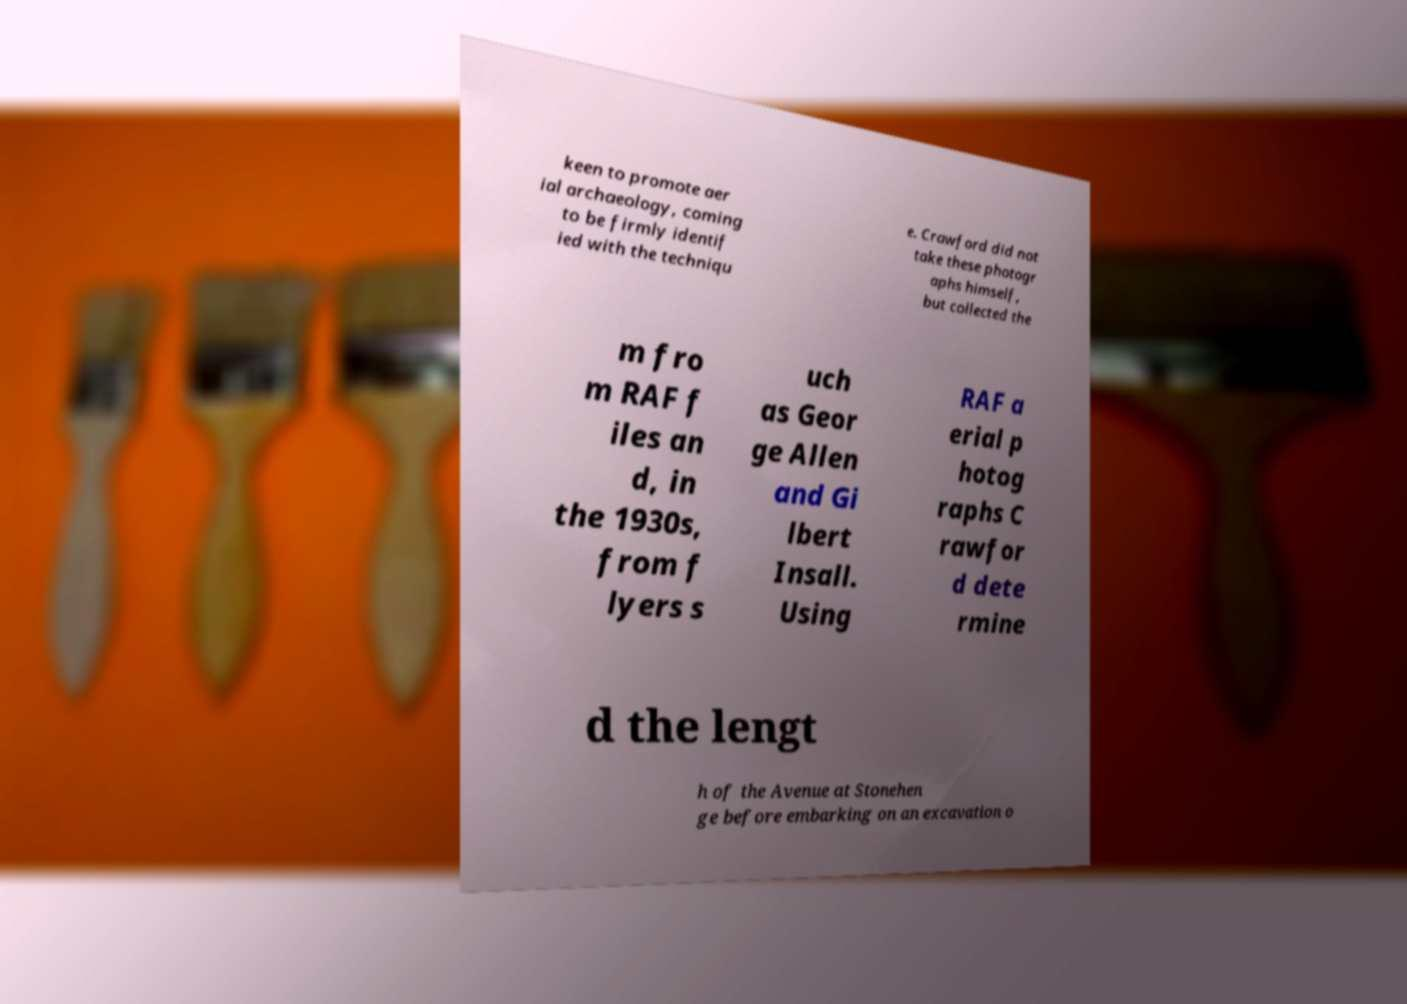Please read and relay the text visible in this image. What does it say? keen to promote aer ial archaeology, coming to be firmly identif ied with the techniqu e. Crawford did not take these photogr aphs himself, but collected the m fro m RAF f iles an d, in the 1930s, from f lyers s uch as Geor ge Allen and Gi lbert Insall. Using RAF a erial p hotog raphs C rawfor d dete rmine d the lengt h of the Avenue at Stonehen ge before embarking on an excavation o 